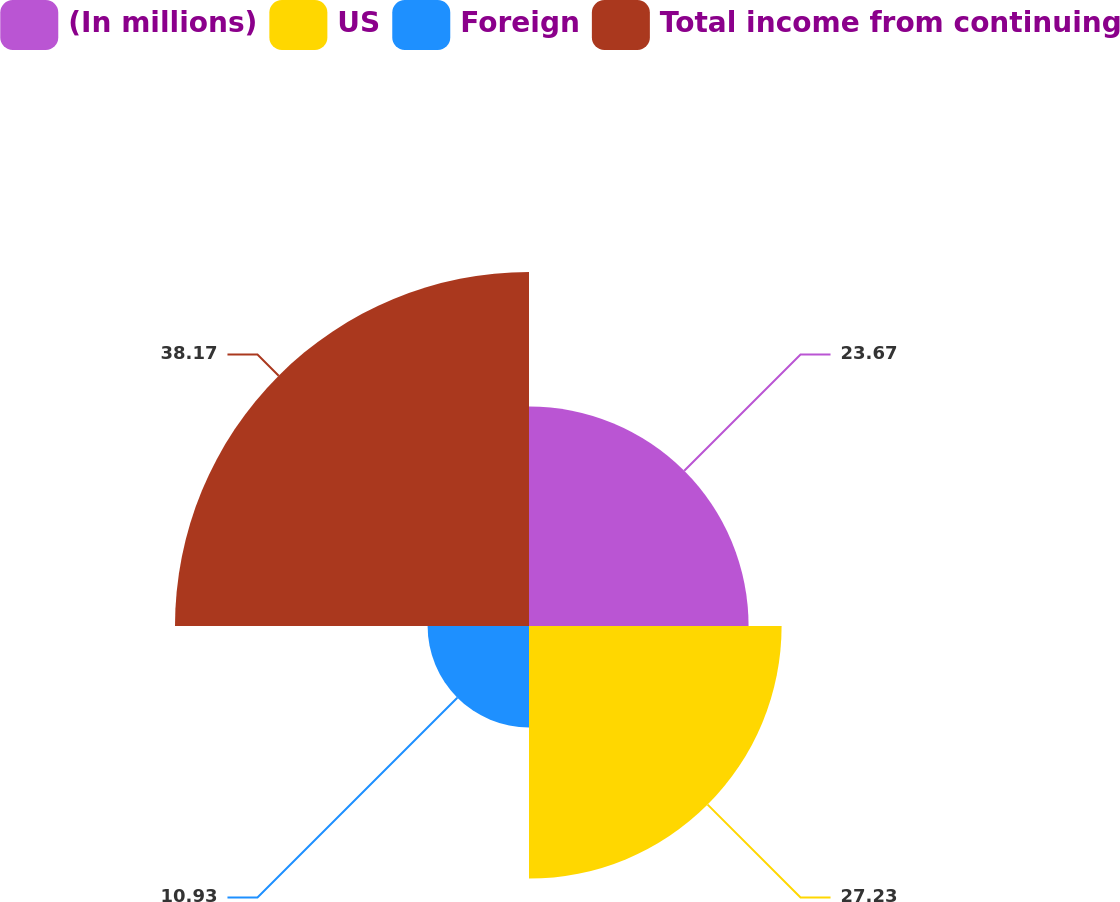Convert chart. <chart><loc_0><loc_0><loc_500><loc_500><pie_chart><fcel>(In millions)<fcel>US<fcel>Foreign<fcel>Total income from continuing<nl><fcel>23.67%<fcel>27.23%<fcel>10.93%<fcel>38.16%<nl></chart> 